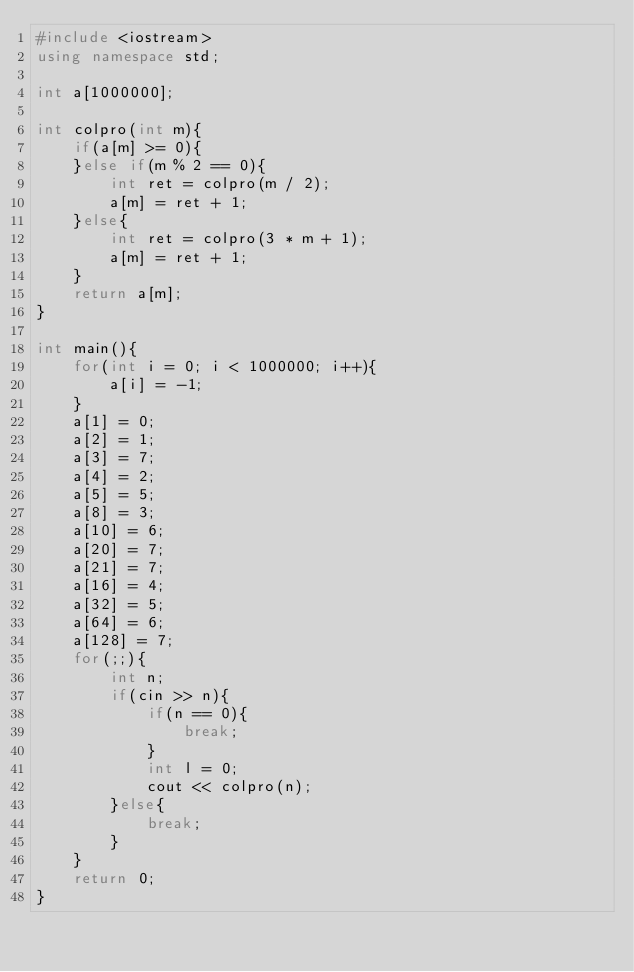<code> <loc_0><loc_0><loc_500><loc_500><_C++_>#include <iostream>
using namespace std;

int a[1000000];

int colpro(int m){
    if(a[m] >= 0){
    }else if(m % 2 == 0){
        int ret = colpro(m / 2);
        a[m] = ret + 1;
    }else{
        int ret = colpro(3 * m + 1);
        a[m] = ret + 1;
    }
    return a[m];
}

int main(){
    for(int i = 0; i < 1000000; i++){
        a[i] = -1;
    }
    a[1] = 0;
    a[2] = 1;
    a[3] = 7;
    a[4] = 2;
    a[5] = 5;
    a[8] = 3;
    a[10] = 6;
    a[20] = 7;
    a[21] = 7;
    a[16] = 4;
    a[32] = 5;
    a[64] = 6;
    a[128] = 7;
    for(;;){
        int n;
        if(cin >> n){
            if(n == 0){
                break;
            }
            int l = 0;
            cout << colpro(n);
        }else{
            break;
        }
    }
    return 0;
}</code> 